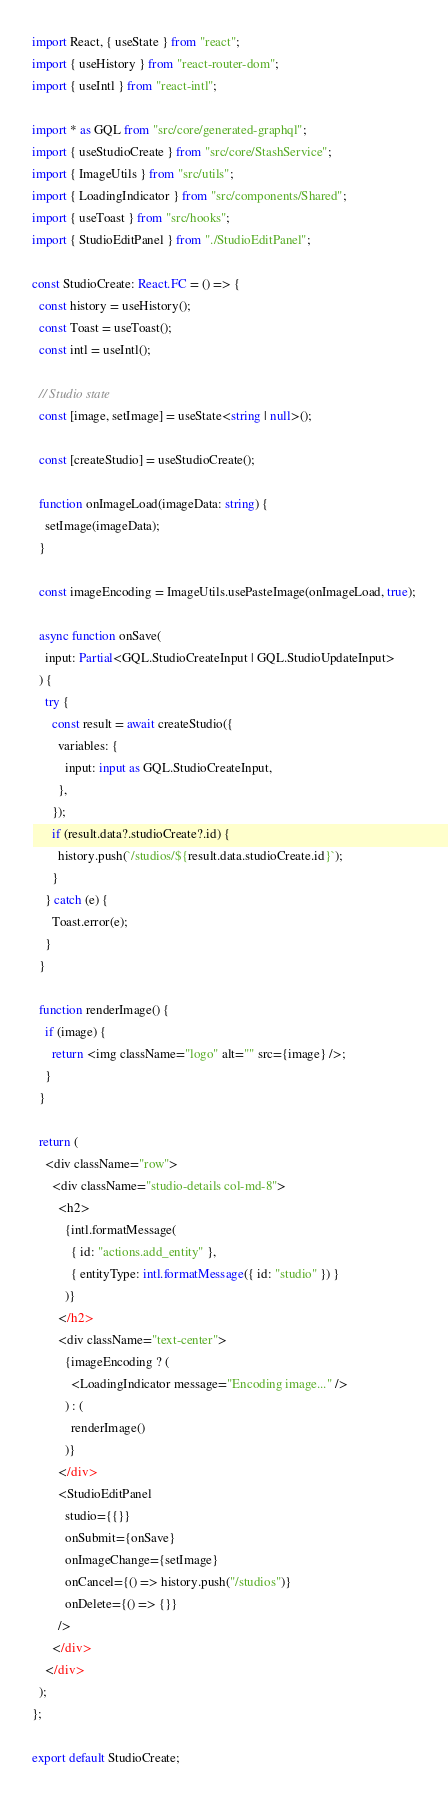Convert code to text. <code><loc_0><loc_0><loc_500><loc_500><_TypeScript_>import React, { useState } from "react";
import { useHistory } from "react-router-dom";
import { useIntl } from "react-intl";

import * as GQL from "src/core/generated-graphql";
import { useStudioCreate } from "src/core/StashService";
import { ImageUtils } from "src/utils";
import { LoadingIndicator } from "src/components/Shared";
import { useToast } from "src/hooks";
import { StudioEditPanel } from "./StudioEditPanel";

const StudioCreate: React.FC = () => {
  const history = useHistory();
  const Toast = useToast();
  const intl = useIntl();

  // Studio state
  const [image, setImage] = useState<string | null>();

  const [createStudio] = useStudioCreate();

  function onImageLoad(imageData: string) {
    setImage(imageData);
  }

  const imageEncoding = ImageUtils.usePasteImage(onImageLoad, true);

  async function onSave(
    input: Partial<GQL.StudioCreateInput | GQL.StudioUpdateInput>
  ) {
    try {
      const result = await createStudio({
        variables: {
          input: input as GQL.StudioCreateInput,
        },
      });
      if (result.data?.studioCreate?.id) {
        history.push(`/studios/${result.data.studioCreate.id}`);
      }
    } catch (e) {
      Toast.error(e);
    }
  }

  function renderImage() {
    if (image) {
      return <img className="logo" alt="" src={image} />;
    }
  }

  return (
    <div className="row">
      <div className="studio-details col-md-8">
        <h2>
          {intl.formatMessage(
            { id: "actions.add_entity" },
            { entityType: intl.formatMessage({ id: "studio" }) }
          )}
        </h2>
        <div className="text-center">
          {imageEncoding ? (
            <LoadingIndicator message="Encoding image..." />
          ) : (
            renderImage()
          )}
        </div>
        <StudioEditPanel
          studio={{}}
          onSubmit={onSave}
          onImageChange={setImage}
          onCancel={() => history.push("/studios")}
          onDelete={() => {}}
        />
      </div>
    </div>
  );
};

export default StudioCreate;
</code> 